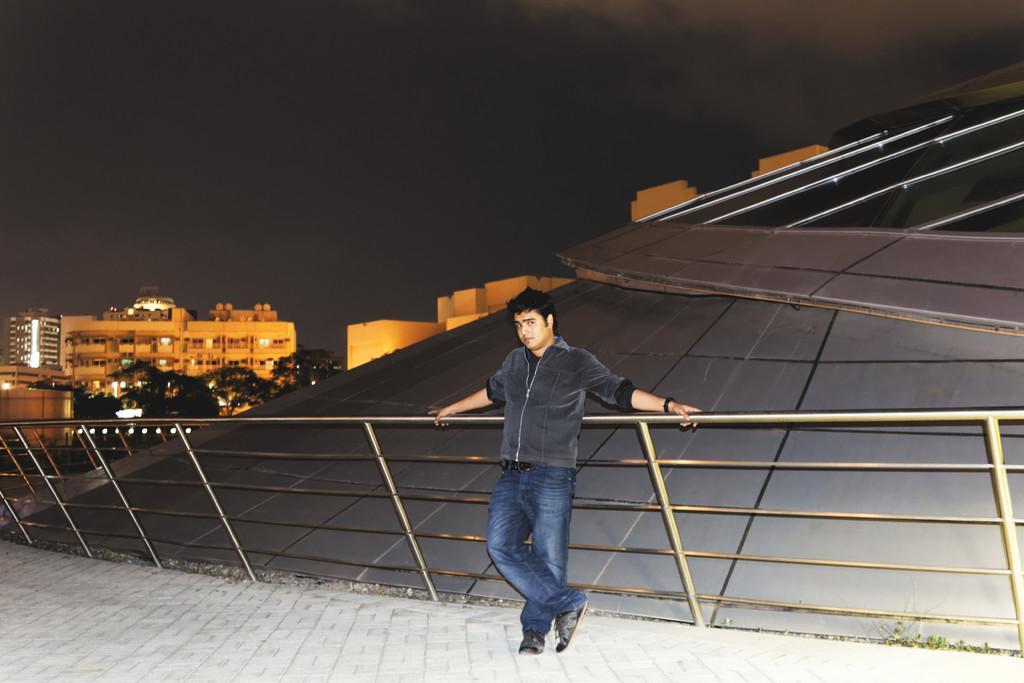Can you describe this image briefly? In this image I can see a man is standing, he wore coat, trouser. On the left side there are trees and buildings. At the top it is the sky. 